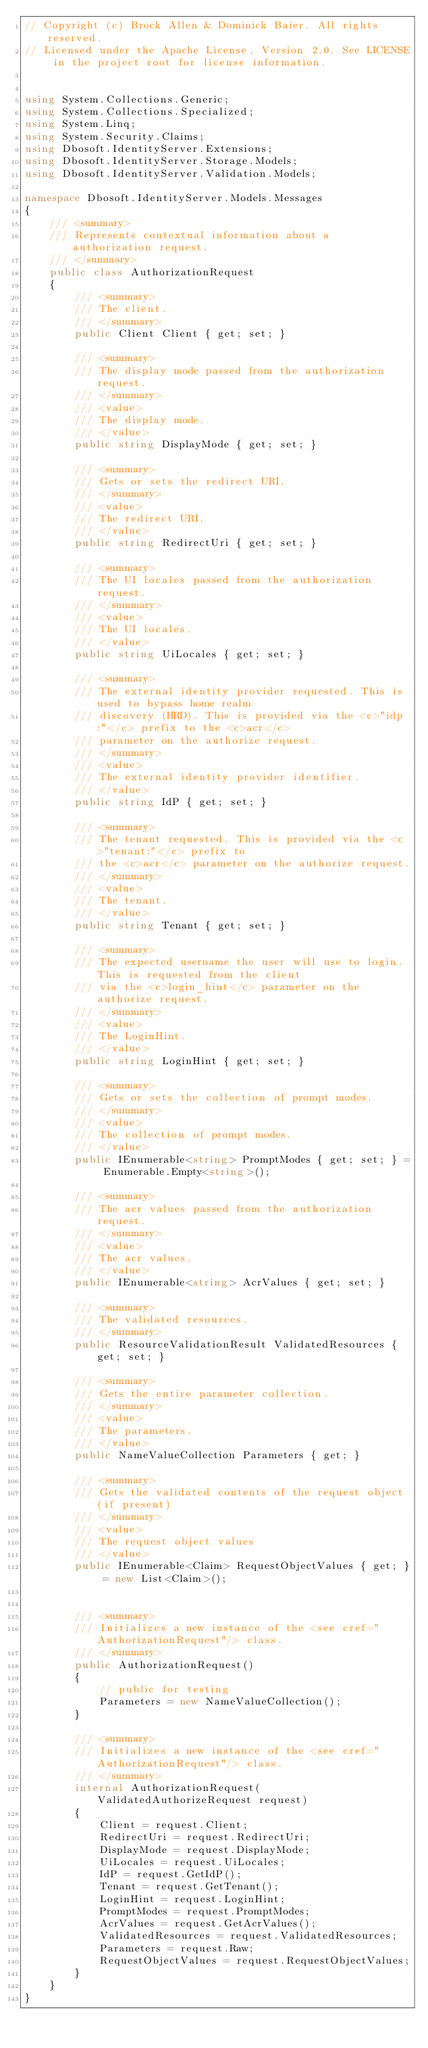Convert code to text. <code><loc_0><loc_0><loc_500><loc_500><_C#_>// Copyright (c) Brock Allen & Dominick Baier. All rights reserved.
// Licensed under the Apache License, Version 2.0. See LICENSE in the project root for license information.


using System.Collections.Generic;
using System.Collections.Specialized;
using System.Linq;
using System.Security.Claims;
using Dbosoft.IdentityServer.Extensions;
using Dbosoft.IdentityServer.Storage.Models;
using Dbosoft.IdentityServer.Validation.Models;

namespace Dbosoft.IdentityServer.Models.Messages
{
    /// <summary>
    /// Represents contextual information about a authorization request.
    /// </summary>
    public class AuthorizationRequest
    {
        /// <summary>
        /// The client.
        /// </summary>
        public Client Client { get; set; }

        /// <summary>
        /// The display mode passed from the authorization request.
        /// </summary>
        /// <value>
        /// The display mode.
        /// </value>
        public string DisplayMode { get; set; }

        /// <summary>
        /// Gets or sets the redirect URI.
        /// </summary>
        /// <value>
        /// The redirect URI.
        /// </value>
        public string RedirectUri { get; set; }

        /// <summary>
        /// The UI locales passed from the authorization request.
        /// </summary>
        /// <value>
        /// The UI locales.
        /// </value>
        public string UiLocales { get; set; }

        /// <summary>
        /// The external identity provider requested. This is used to bypass home realm 
        /// discovery (HRD). This is provided via the <c>"idp:"</c> prefix to the <c>acr</c> 
        /// parameter on the authorize request.
        /// </summary>
        /// <value>
        /// The external identity provider identifier.
        /// </value>
        public string IdP { get; set; }

        /// <summary>
        /// The tenant requested. This is provided via the <c>"tenant:"</c> prefix to 
        /// the <c>acr</c> parameter on the authorize request.
        /// </summary>
        /// <value>
        /// The tenant.
        /// </value>
        public string Tenant { get; set; }

        /// <summary>
        /// The expected username the user will use to login. This is requested from the client 
        /// via the <c>login_hint</c> parameter on the authorize request.
        /// </summary>
        /// <value>
        /// The LoginHint.
        /// </value>
        public string LoginHint { get; set; }

        /// <summary>
        /// Gets or sets the collection of prompt modes.
        /// </summary>
        /// <value>
        /// The collection of prompt modes.
        /// </value>
        public IEnumerable<string> PromptModes { get; set; } = Enumerable.Empty<string>();

        /// <summary>
        /// The acr values passed from the authorization request.
        /// </summary>
        /// <value>
        /// The acr values.
        /// </value>
        public IEnumerable<string> AcrValues { get; set; }

        /// <summary>
        /// The validated resources.
        /// </summary>
        public ResourceValidationResult ValidatedResources { get; set; }

        /// <summary>
        /// Gets the entire parameter collection.
        /// </summary>
        /// <value>
        /// The parameters.
        /// </value>
        public NameValueCollection Parameters { get; }

        /// <summary>
        /// Gets the validated contents of the request object (if present)
        /// </summary>
        /// <value>
        /// The request object values
        /// </value>
        public IEnumerable<Claim> RequestObjectValues { get; } = new List<Claim>();


        /// <summary>
        /// Initializes a new instance of the <see cref="AuthorizationRequest"/> class.
        /// </summary>
        public AuthorizationRequest()
        {
            // public for testing
            Parameters = new NameValueCollection();
        }

        /// <summary>
        /// Initializes a new instance of the <see cref="AuthorizationRequest"/> class.
        /// </summary>
        internal AuthorizationRequest(ValidatedAuthorizeRequest request)
        {
            Client = request.Client;
            RedirectUri = request.RedirectUri;
            DisplayMode = request.DisplayMode;
            UiLocales = request.UiLocales;
            IdP = request.GetIdP();
            Tenant = request.GetTenant();
            LoginHint = request.LoginHint;
            PromptModes = request.PromptModes;
            AcrValues = request.GetAcrValues();
            ValidatedResources = request.ValidatedResources;
            Parameters = request.Raw;
            RequestObjectValues = request.RequestObjectValues;
        }
    }
}</code> 